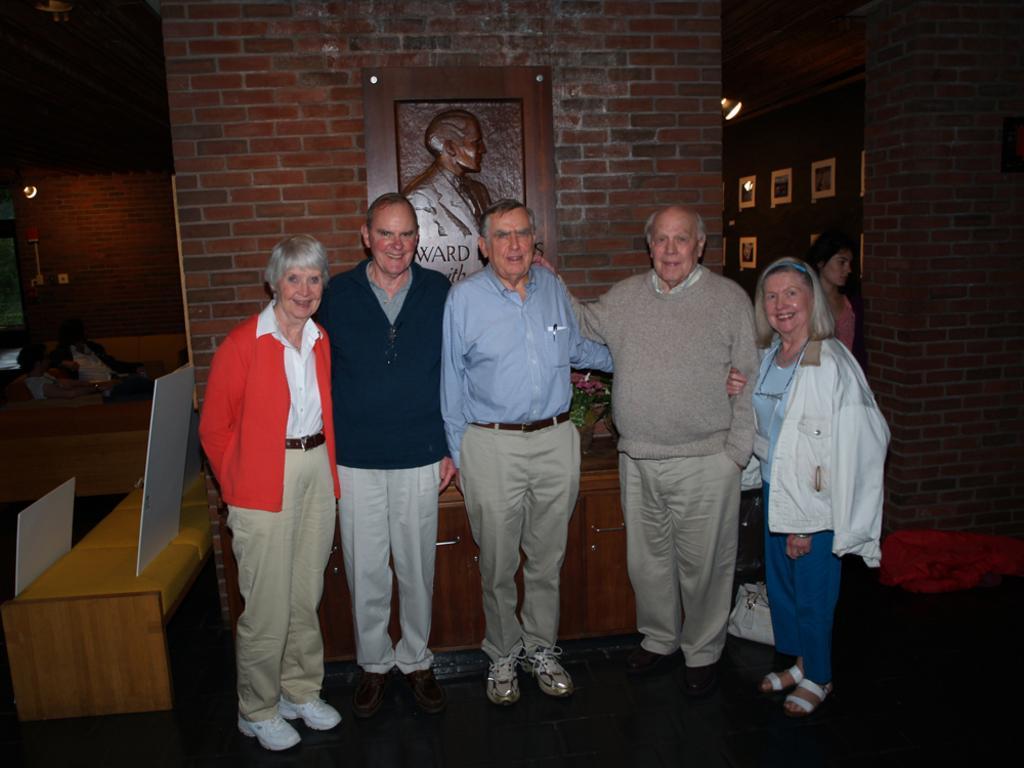Describe this image in one or two sentences. In this image, we can see a group of people are standing, seeing and smiling. Here we can see wall, some art, photo frames, bag. Background we can see few people. Few are sitting. Here we can see lights, desk, table, boards. 